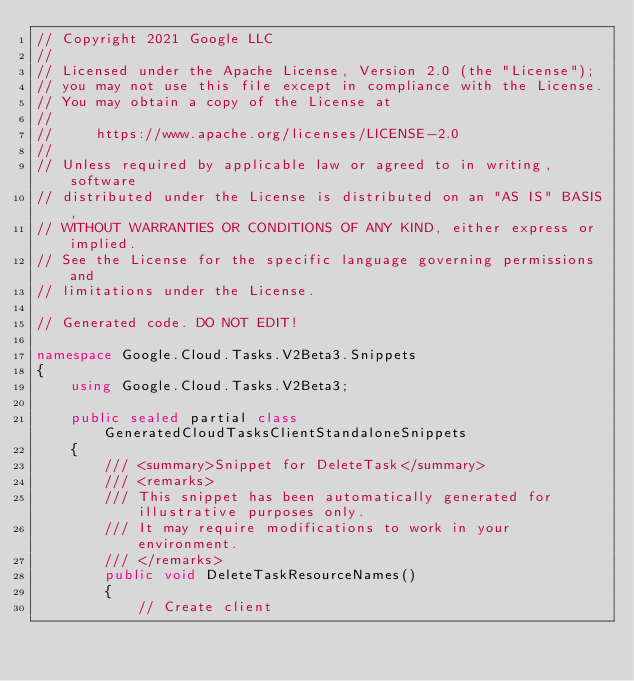Convert code to text. <code><loc_0><loc_0><loc_500><loc_500><_C#_>// Copyright 2021 Google LLC
//
// Licensed under the Apache License, Version 2.0 (the "License");
// you may not use this file except in compliance with the License.
// You may obtain a copy of the License at
//
//     https://www.apache.org/licenses/LICENSE-2.0
//
// Unless required by applicable law or agreed to in writing, software
// distributed under the License is distributed on an "AS IS" BASIS,
// WITHOUT WARRANTIES OR CONDITIONS OF ANY KIND, either express or implied.
// See the License for the specific language governing permissions and
// limitations under the License.

// Generated code. DO NOT EDIT!

namespace Google.Cloud.Tasks.V2Beta3.Snippets
{
    using Google.Cloud.Tasks.V2Beta3;

    public sealed partial class GeneratedCloudTasksClientStandaloneSnippets
    {
        /// <summary>Snippet for DeleteTask</summary>
        /// <remarks>
        /// This snippet has been automatically generated for illustrative purposes only.
        /// It may require modifications to work in your environment.
        /// </remarks>
        public void DeleteTaskResourceNames()
        {
            // Create client</code> 